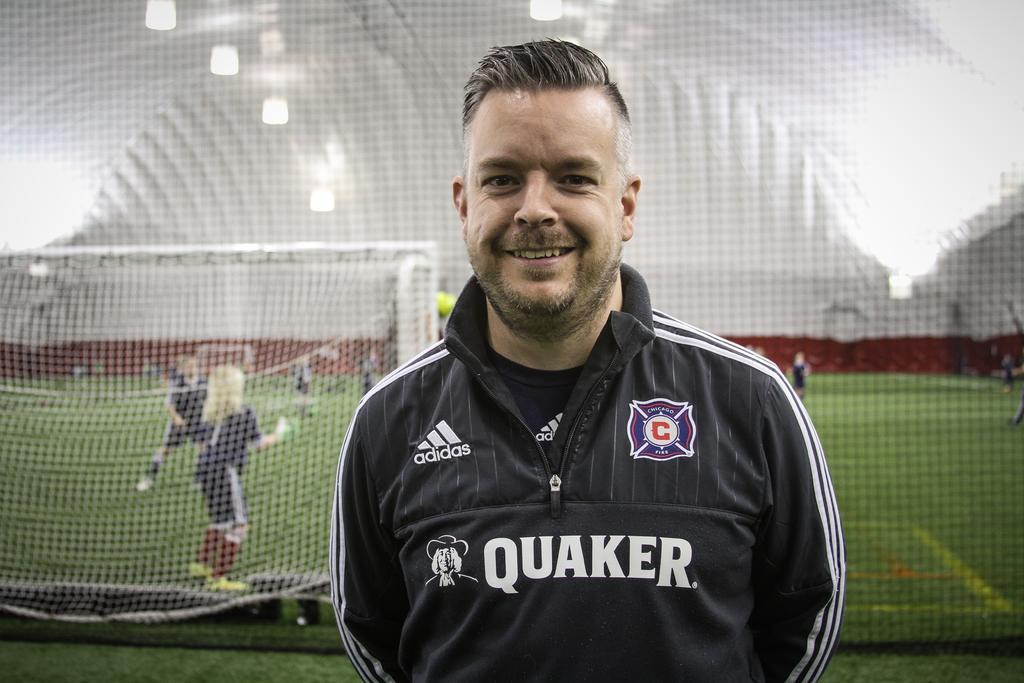How would you summarize this image in a sentence or two? In this image, we can see a person is watching and smiling. Background we can see net, rods, few people and ground. 